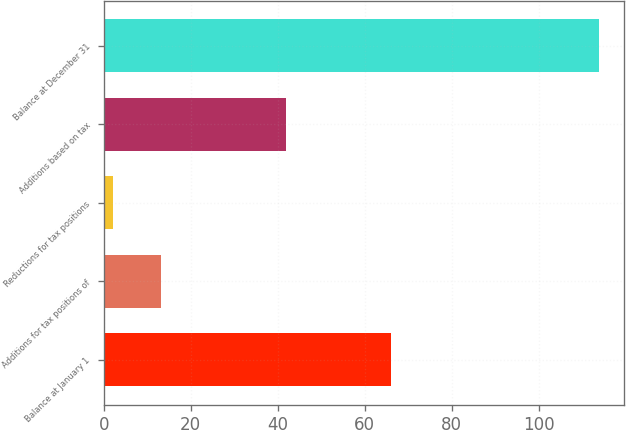<chart> <loc_0><loc_0><loc_500><loc_500><bar_chart><fcel>Balance at January 1<fcel>Additions for tax positions of<fcel>Reductions for tax positions<fcel>Additions based on tax<fcel>Balance at December 31<nl><fcel>66<fcel>13.2<fcel>2<fcel>42<fcel>114<nl></chart> 